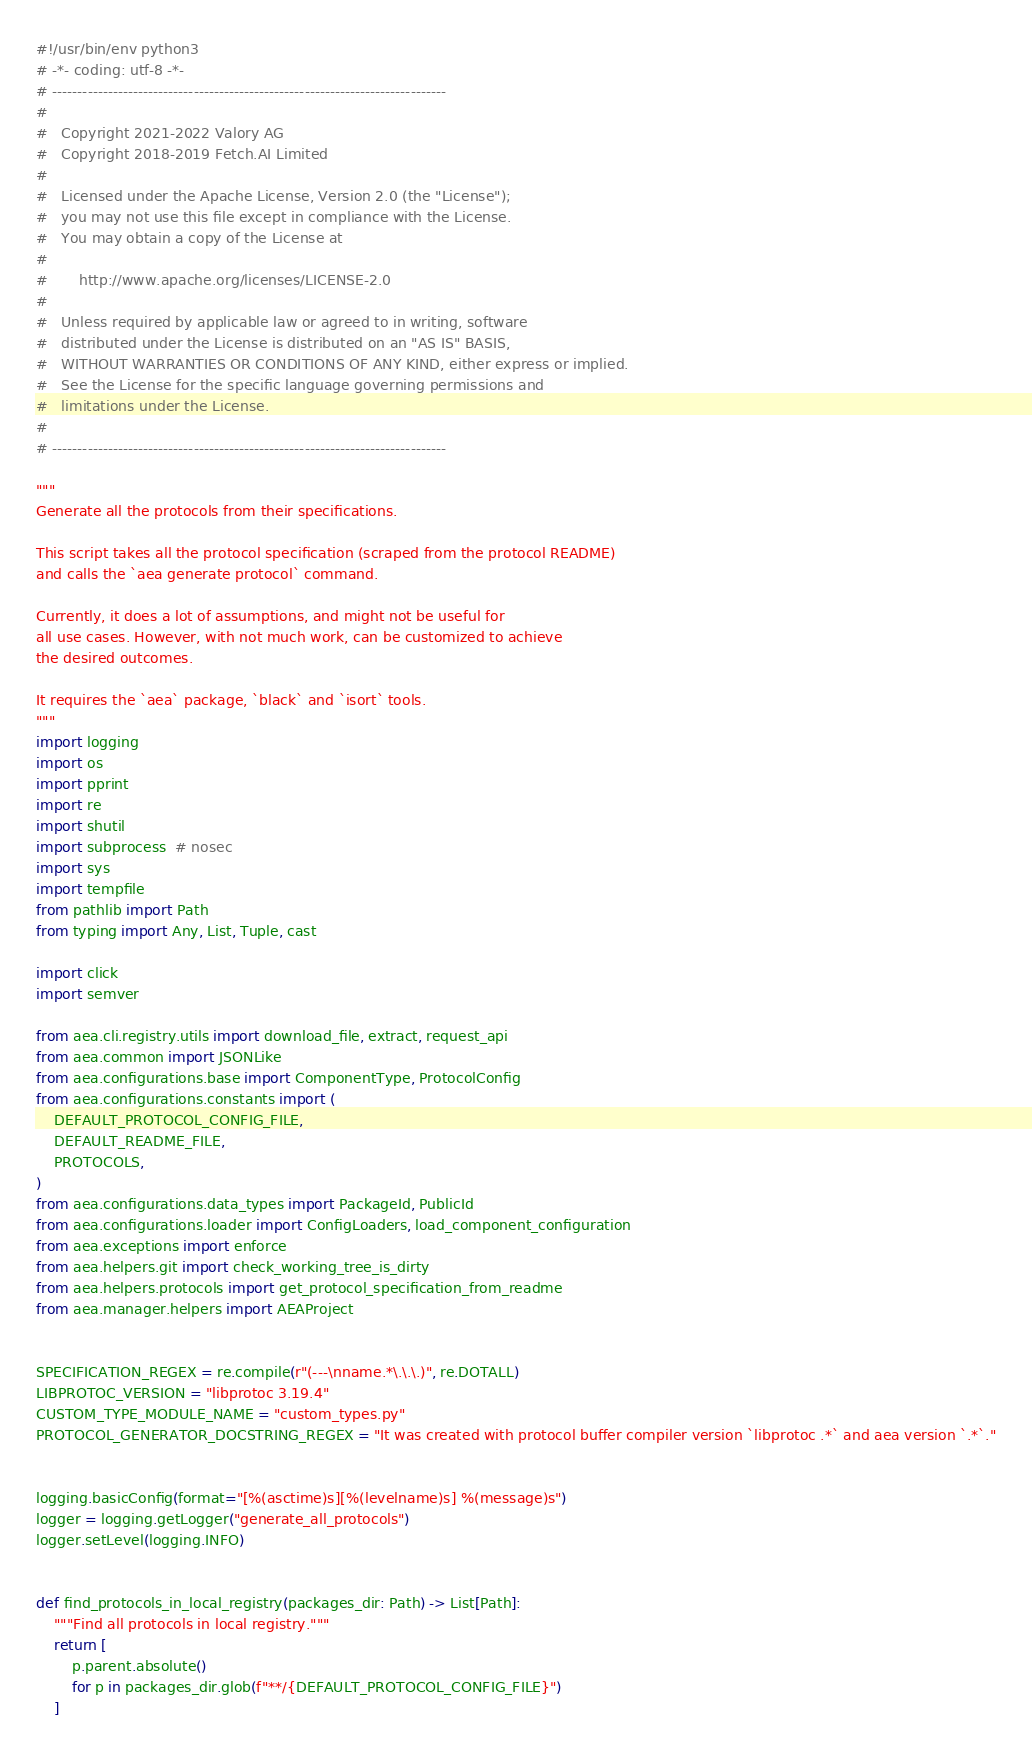<code> <loc_0><loc_0><loc_500><loc_500><_Python_>#!/usr/bin/env python3
# -*- coding: utf-8 -*-
# ------------------------------------------------------------------------------
#
#   Copyright 2021-2022 Valory AG
#   Copyright 2018-2019 Fetch.AI Limited
#
#   Licensed under the Apache License, Version 2.0 (the "License");
#   you may not use this file except in compliance with the License.
#   You may obtain a copy of the License at
#
#       http://www.apache.org/licenses/LICENSE-2.0
#
#   Unless required by applicable law or agreed to in writing, software
#   distributed under the License is distributed on an "AS IS" BASIS,
#   WITHOUT WARRANTIES OR CONDITIONS OF ANY KIND, either express or implied.
#   See the License for the specific language governing permissions and
#   limitations under the License.
#
# ------------------------------------------------------------------------------

"""
Generate all the protocols from their specifications.

This script takes all the protocol specification (scraped from the protocol README)
and calls the `aea generate protocol` command.

Currently, it does a lot of assumptions, and might not be useful for
all use cases. However, with not much work, can be customized to achieve
the desired outcomes.

It requires the `aea` package, `black` and `isort` tools.
"""
import logging
import os
import pprint
import re
import shutil
import subprocess  # nosec
import sys
import tempfile
from pathlib import Path
from typing import Any, List, Tuple, cast

import click
import semver

from aea.cli.registry.utils import download_file, extract, request_api
from aea.common import JSONLike
from aea.configurations.base import ComponentType, ProtocolConfig
from aea.configurations.constants import (
    DEFAULT_PROTOCOL_CONFIG_FILE,
    DEFAULT_README_FILE,
    PROTOCOLS,
)
from aea.configurations.data_types import PackageId, PublicId
from aea.configurations.loader import ConfigLoaders, load_component_configuration
from aea.exceptions import enforce
from aea.helpers.git import check_working_tree_is_dirty
from aea.helpers.protocols import get_protocol_specification_from_readme
from aea.manager.helpers import AEAProject


SPECIFICATION_REGEX = re.compile(r"(---\nname.*\.\.\.)", re.DOTALL)
LIBPROTOC_VERSION = "libprotoc 3.19.4"
CUSTOM_TYPE_MODULE_NAME = "custom_types.py"
PROTOCOL_GENERATOR_DOCSTRING_REGEX = "It was created with protocol buffer compiler version `libprotoc .*` and aea version `.*`."


logging.basicConfig(format="[%(asctime)s][%(levelname)s] %(message)s")
logger = logging.getLogger("generate_all_protocols")
logger.setLevel(logging.INFO)


def find_protocols_in_local_registry(packages_dir: Path) -> List[Path]:
    """Find all protocols in local registry."""
    return [
        p.parent.absolute()
        for p in packages_dir.glob(f"**/{DEFAULT_PROTOCOL_CONFIG_FILE}")
    ]

</code> 